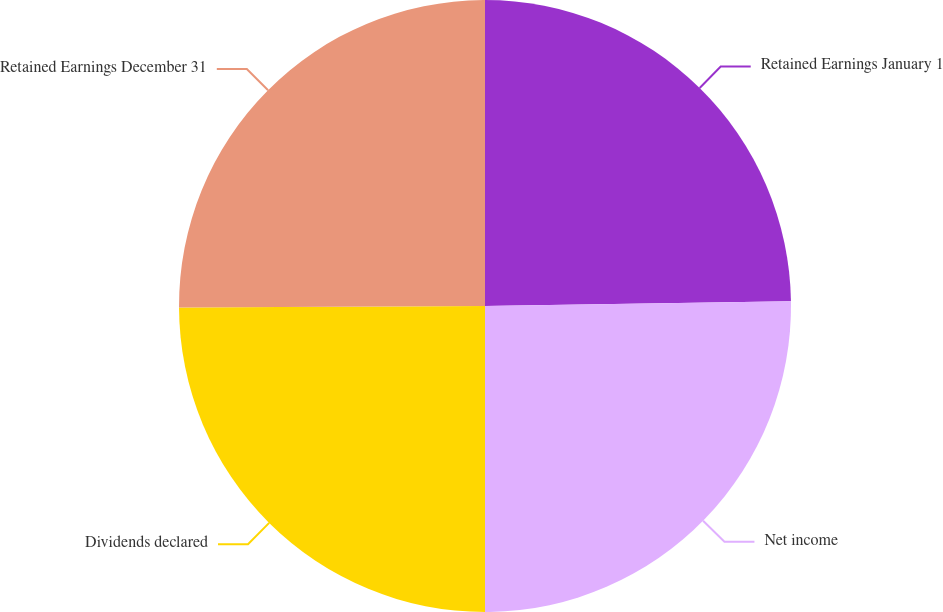Convert chart. <chart><loc_0><loc_0><loc_500><loc_500><pie_chart><fcel>Retained Earnings January 1<fcel>Net income<fcel>Dividends declared<fcel>Retained Earnings December 31<nl><fcel>24.75%<fcel>25.25%<fcel>24.92%<fcel>25.08%<nl></chart> 